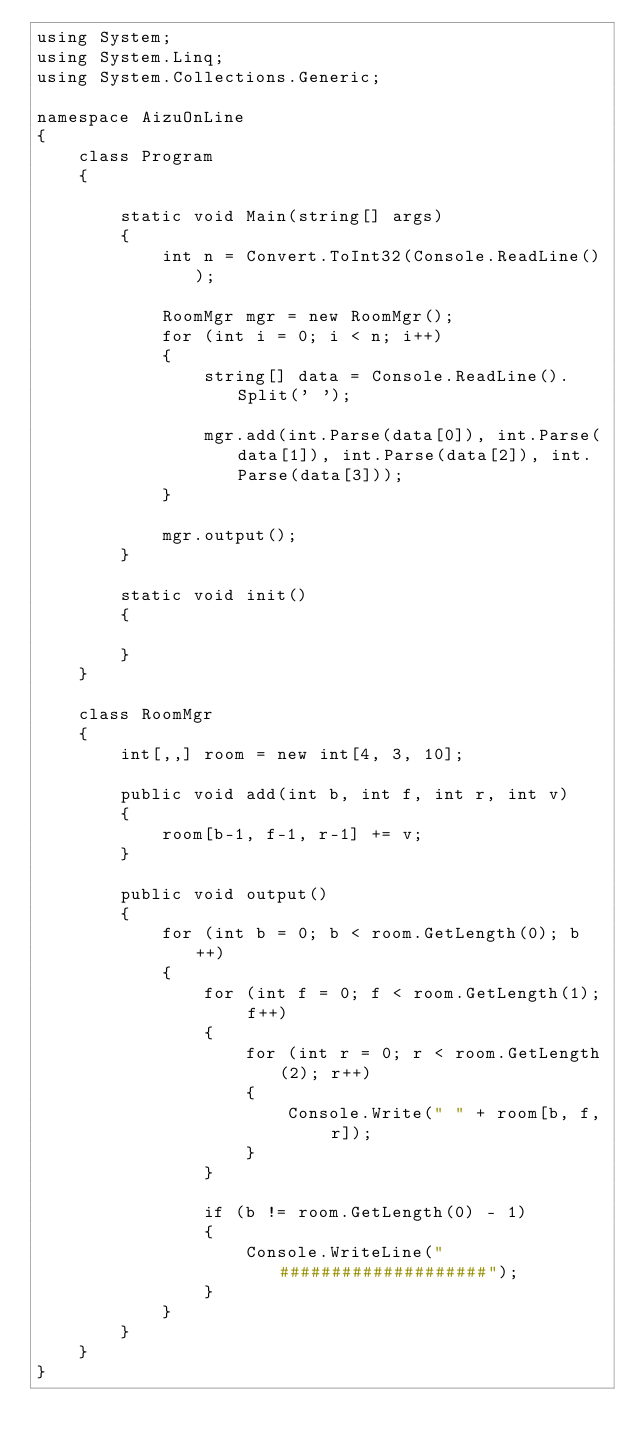<code> <loc_0><loc_0><loc_500><loc_500><_C#_>using System;
using System.Linq;
using System.Collections.Generic;

namespace AizuOnLine
{
    class Program
    {
        
        static void Main(string[] args)
        {
            int n = Convert.ToInt32(Console.ReadLine());

            RoomMgr mgr = new RoomMgr();
            for (int i = 0; i < n; i++)
            {
                string[] data = Console.ReadLine().Split(' ');

                mgr.add(int.Parse(data[0]), int.Parse(data[1]), int.Parse(data[2]), int.Parse(data[3]));
            }

            mgr.output();
        }

        static void init()
        {

        }
    }

    class RoomMgr
    {
        int[,,] room = new int[4, 3, 10];
        
        public void add(int b, int f, int r, int v)
        {
            room[b-1, f-1, r-1] += v;
        }

        public void output()
        {
            for (int b = 0; b < room.GetLength(0); b++)
            {
                for (int f = 0; f < room.GetLength(1); f++)
                {
                    for (int r = 0; r < room.GetLength(2); r++)
                    {
                        Console.Write(" " + room[b, f, r]);
                    }
                }

                if (b != room.GetLength(0) - 1)
                {
                    Console.WriteLine("####################");
                }
            }
        }
    }
}</code> 